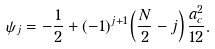Convert formula to latex. <formula><loc_0><loc_0><loc_500><loc_500>\psi _ { j } = - \frac { 1 } { 2 } + ( - 1 ) ^ { j + 1 } \left ( \frac { N } { 2 } - j \right ) \frac { a _ { c } ^ { 2 } } { 1 2 } .</formula> 